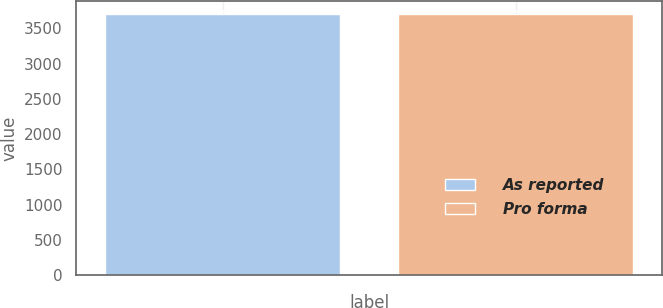Convert chart to OTSL. <chart><loc_0><loc_0><loc_500><loc_500><bar_chart><fcel>As reported<fcel>Pro forma<nl><fcel>3710<fcel>3710.1<nl></chart> 